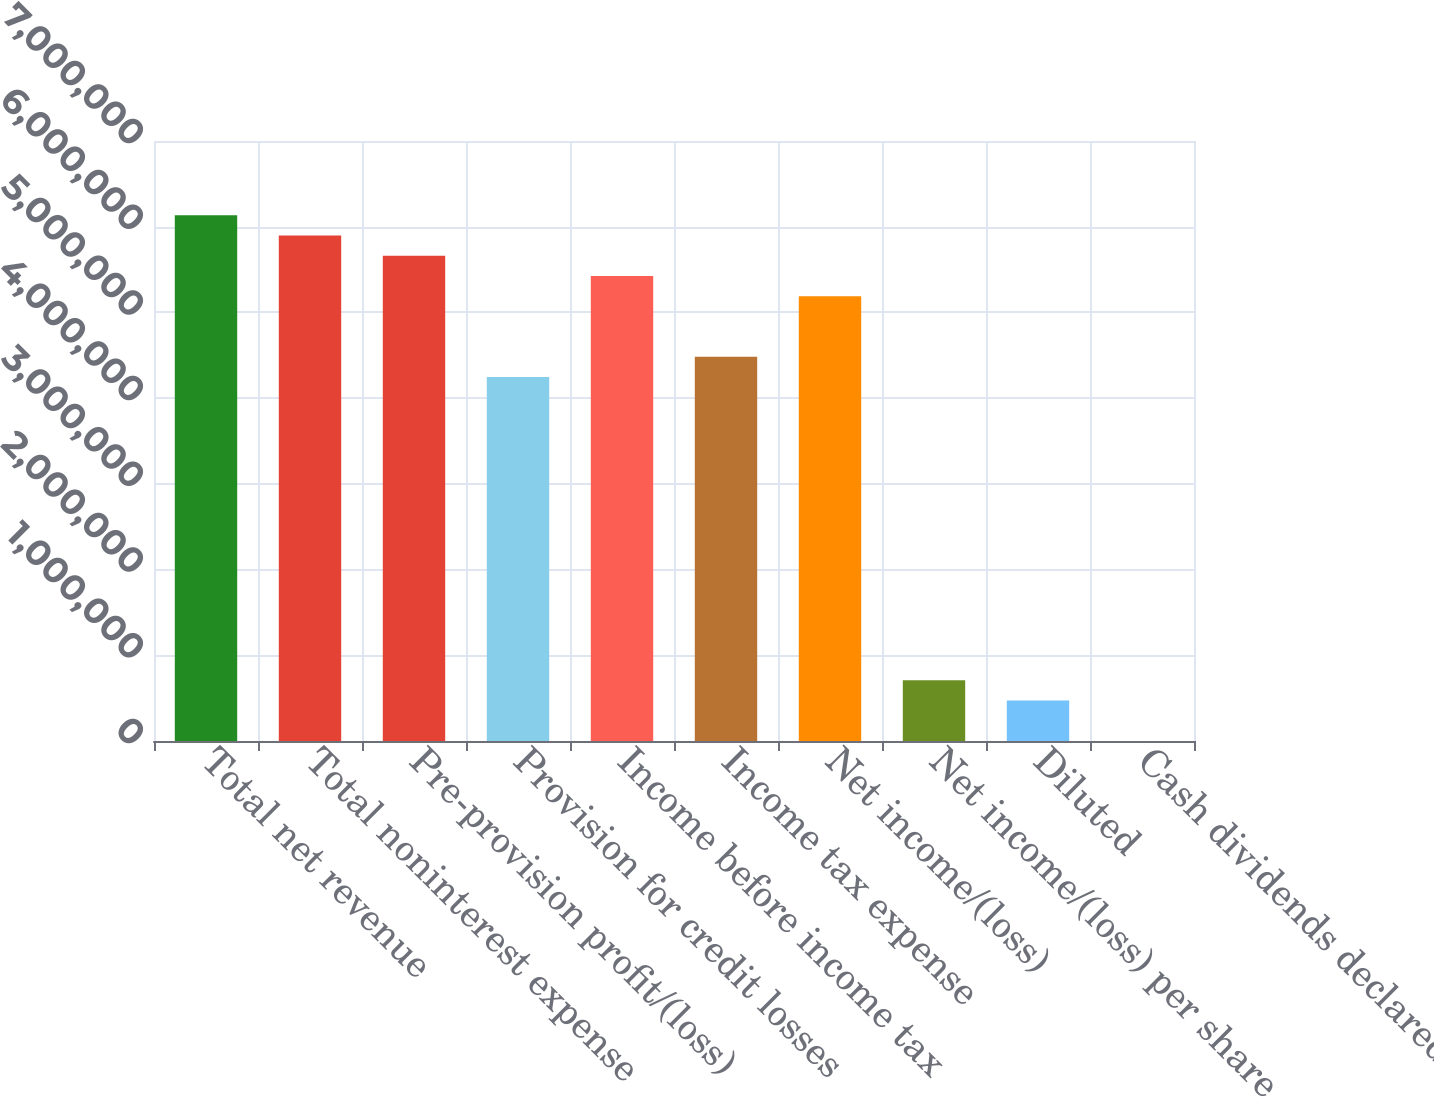Convert chart to OTSL. <chart><loc_0><loc_0><loc_500><loc_500><bar_chart><fcel>Total net revenue<fcel>Total noninterest expense<fcel>Pre-provision profit/(loss)<fcel>Provision for credit losses<fcel>Income before income tax<fcel>Income tax expense<fcel>Net income/(loss)<fcel>Net income/(loss) per share<fcel>Diluted<fcel>Cash dividends declared per<nl><fcel>6.13377e+06<fcel>5.89785e+06<fcel>5.66194e+06<fcel>4.24645e+06<fcel>5.42602e+06<fcel>4.48237e+06<fcel>5.19011e+06<fcel>707743<fcel>471828<fcel>0.3<nl></chart> 